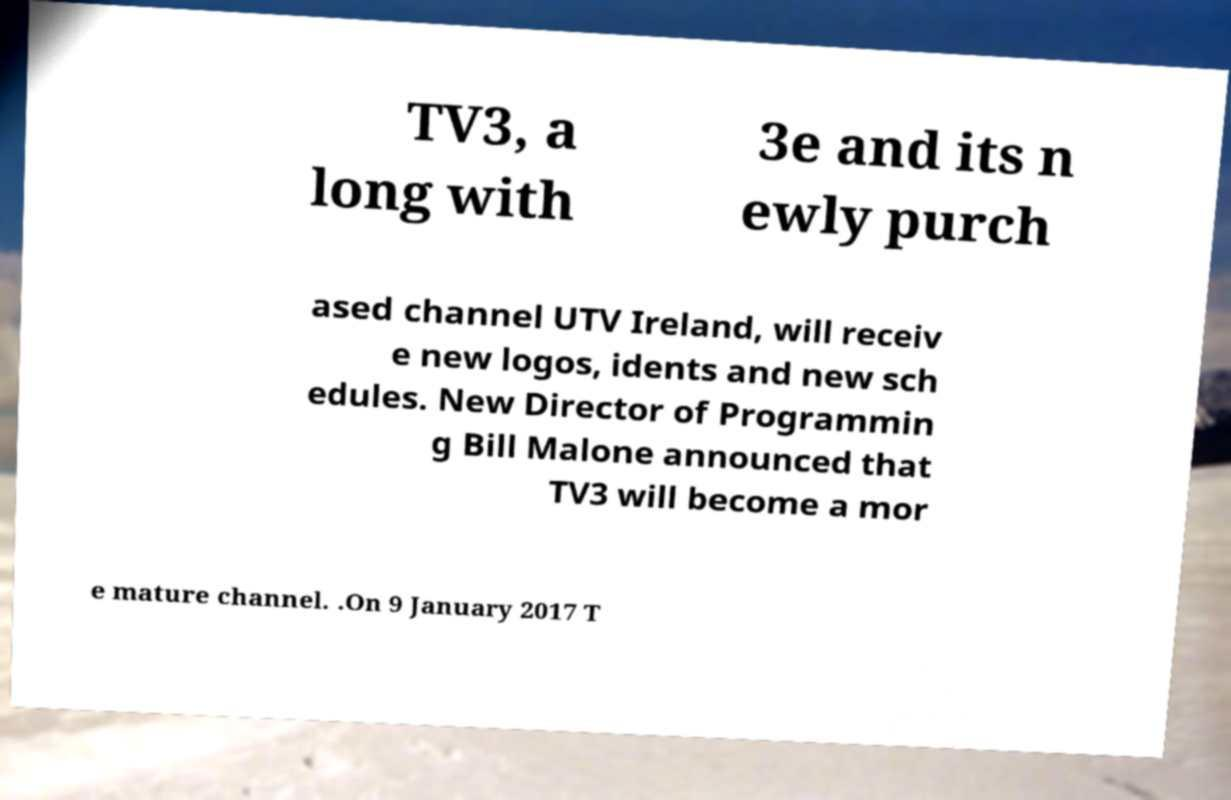Could you assist in decoding the text presented in this image and type it out clearly? TV3, a long with 3e and its n ewly purch ased channel UTV Ireland, will receiv e new logos, idents and new sch edules. New Director of Programmin g Bill Malone announced that TV3 will become a mor e mature channel. .On 9 January 2017 T 